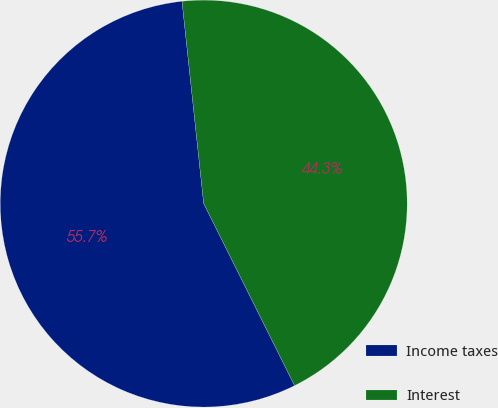Convert chart to OTSL. <chart><loc_0><loc_0><loc_500><loc_500><pie_chart><fcel>Income taxes<fcel>Interest<nl><fcel>55.67%<fcel>44.33%<nl></chart> 